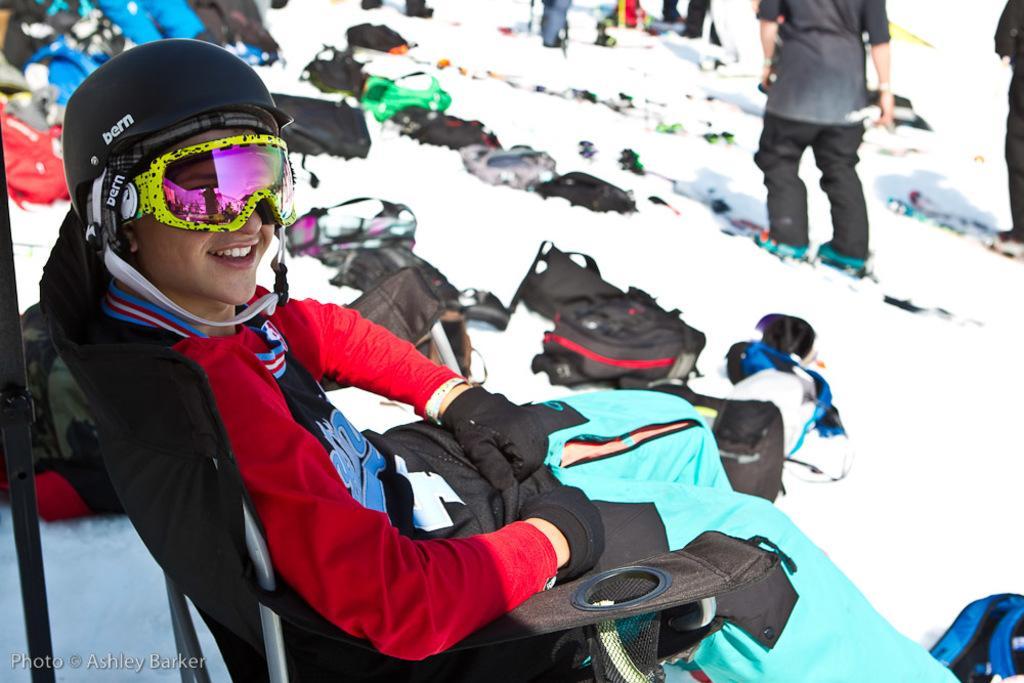In one or two sentences, can you explain what this image depicts? There is a woman sitting on the chair. This is snow. Here we can see bags and few persons. 